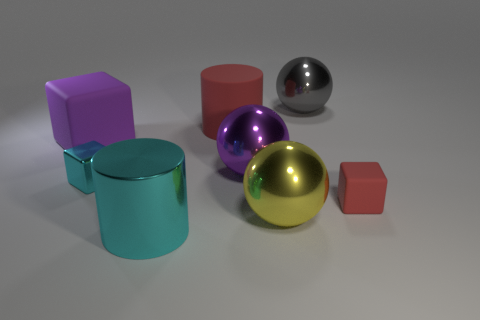Is the number of metal spheres that are right of the cyan cylinder greater than the number of blue spheres?
Your answer should be very brief. Yes. Is there a large thing that has the same color as the tiny shiny thing?
Keep it short and to the point. Yes. What is the size of the red cylinder?
Your answer should be compact. Large. Is the color of the small shiny thing the same as the large metallic cylinder?
Provide a succinct answer. Yes. How many things are either big gray rubber cylinders or large shiny things behind the large cyan metal cylinder?
Provide a short and direct response. 3. There is a large shiny ball that is in front of the rubber block that is on the right side of the big yellow object; what number of small rubber cubes are to the right of it?
Offer a terse response. 1. There is a small object that is the same color as the matte cylinder; what is its material?
Your answer should be compact. Rubber. What number of tiny gray matte blocks are there?
Provide a short and direct response. 0. Does the matte object that is right of the gray ball have the same size as the cyan block?
Provide a succinct answer. Yes. How many shiny objects are either gray cubes or big cyan things?
Offer a very short reply. 1. 